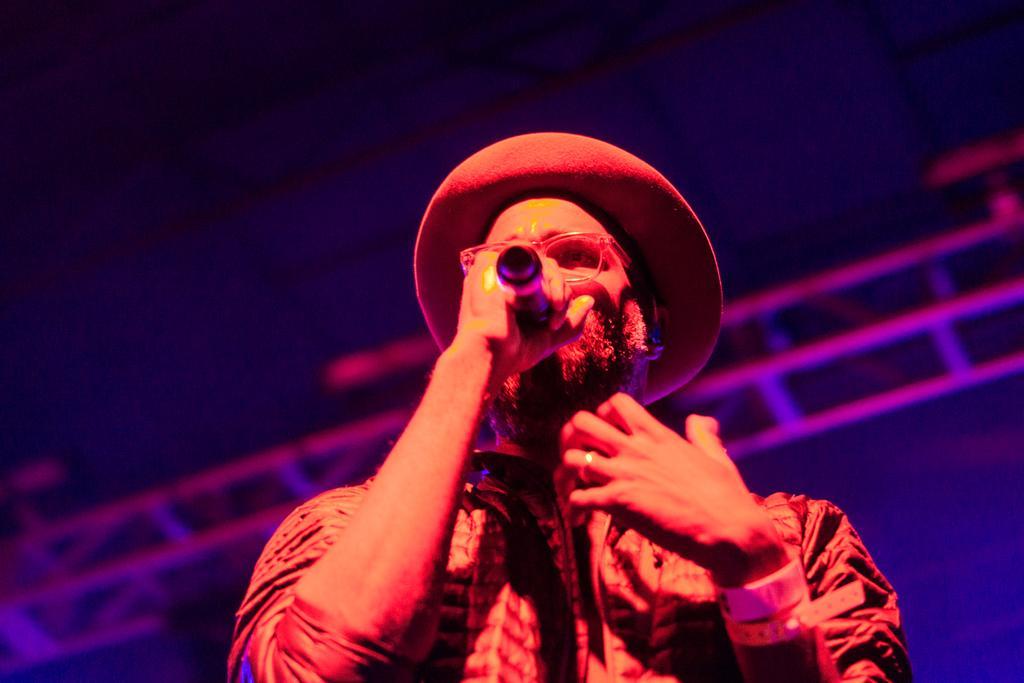Describe this image in one or two sentences. Here in this picture we can see a person standing over a place and singing a song with microphone present in his hand and we can see he is wearing spectacles and hat and we can see some bands on his wrist. 